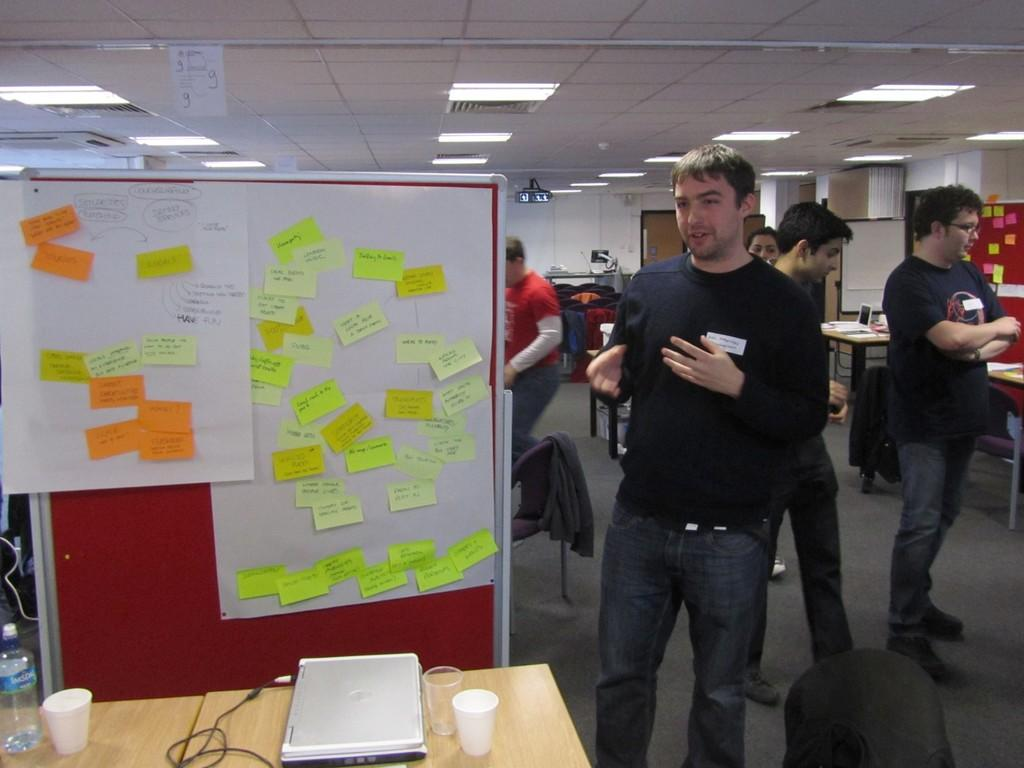Who is present in the image? There is a man in the image. What is the man using in the image? The man is using a board in the image. What can be seen attached to the board? There are quick notes attached to the board. What type of poison is the man using on his wing in the image? There is no mention of poison or wings in the image; the man is using a board with quick notes attached to it. 